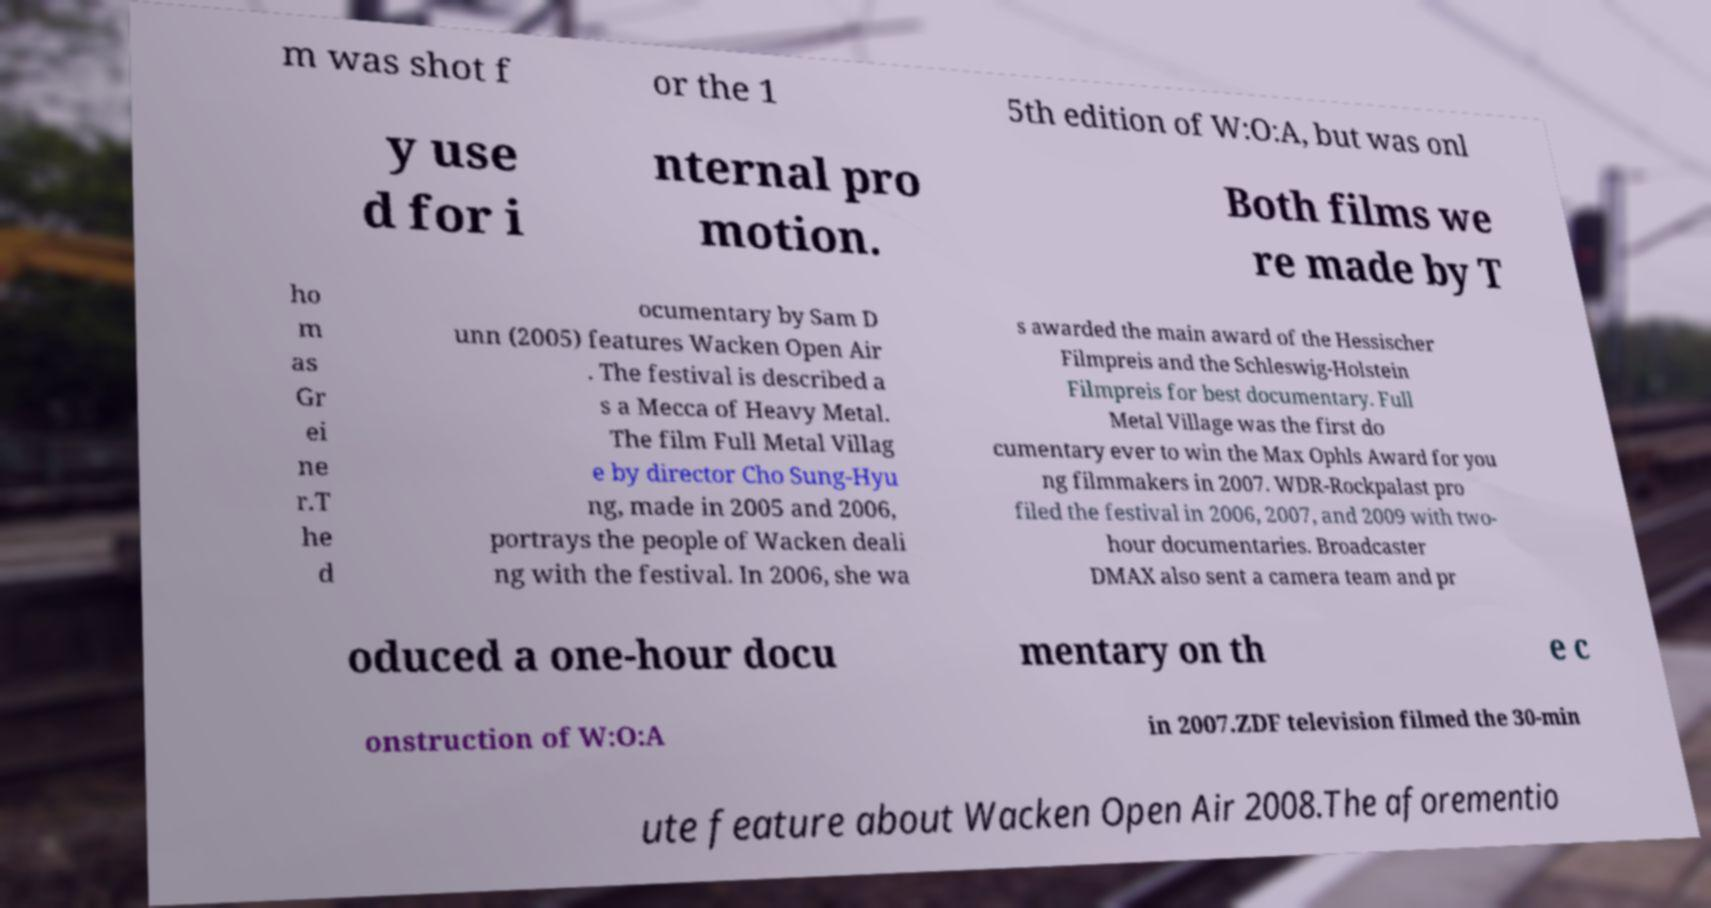Could you extract and type out the text from this image? m was shot f or the 1 5th edition of W:O:A, but was onl y use d for i nternal pro motion. Both films we re made by T ho m as Gr ei ne r.T he d ocumentary by Sam D unn (2005) features Wacken Open Air . The festival is described a s a Mecca of Heavy Metal. The film Full Metal Villag e by director Cho Sung-Hyu ng, made in 2005 and 2006, portrays the people of Wacken deali ng with the festival. In 2006, she wa s awarded the main award of the Hessischer Filmpreis and the Schleswig-Holstein Filmpreis for best documentary. Full Metal Village was the first do cumentary ever to win the Max Ophls Award for you ng filmmakers in 2007. WDR-Rockpalast pro filed the festival in 2006, 2007, and 2009 with two- hour documentaries. Broadcaster DMAX also sent a camera team and pr oduced a one-hour docu mentary on th e c onstruction of W:O:A in 2007.ZDF television filmed the 30-min ute feature about Wacken Open Air 2008.The aforementio 